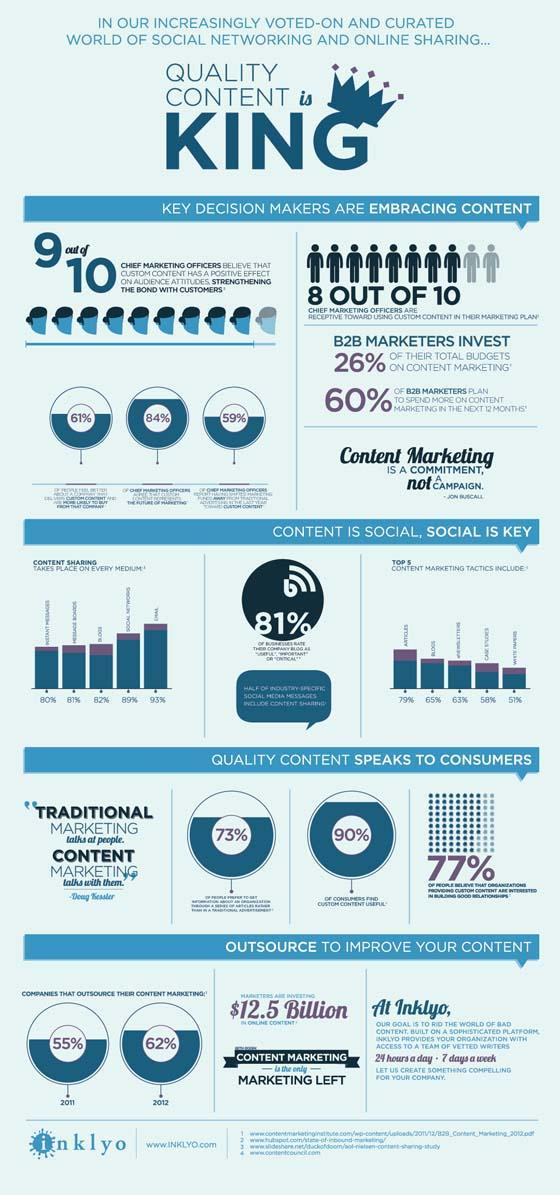What percentage of B2B marketers do not plan to spend more on content marketing in the next 12 months?
Answer the question with a short phrase. 40% What percentage of companies outsources their content marketing in 2012? 62% What percentage of companies outsources their content marketing in 2011? 55% 